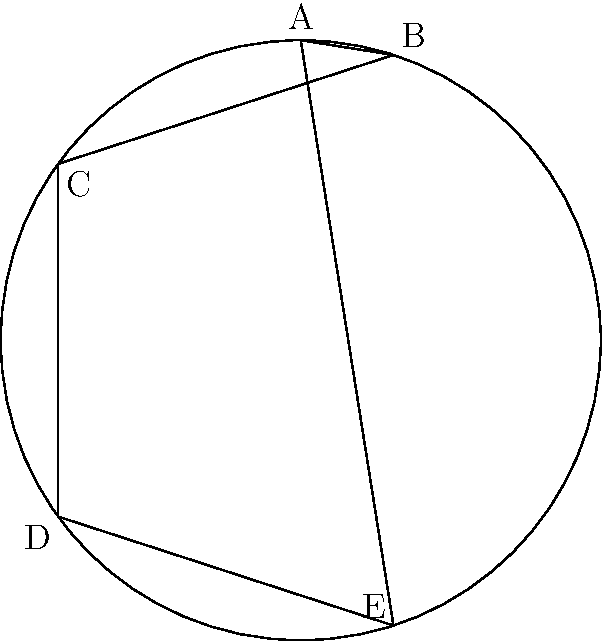In the hyperbolic plane model shown above, a regular pentagon ABCDE is inscribed in a circle. If the sum of the interior angles of this pentagon is $3\pi$ radians, what is the area of the pentagon in terms of $\pi$? Let's approach this step-by-step:

1) In Euclidean geometry, the sum of interior angles of a pentagon is $(5-2)\pi = 3\pi$ radians. However, in hyperbolic geometry, this sum is less than $3\pi$.

2) Let $\alpha$ be the measure of each interior angle of the regular pentagon. Given that the sum is $3\pi$, we have:

   $5\alpha = 3\pi$
   $\alpha = \frac{3\pi}{5}$

3) In hyperbolic geometry, the area of a polygon is given by:

   $Area = (n-2)\pi - \sum \theta_i$

   where $n$ is the number of sides and $\theta_i$ are the interior angles.

4) Substituting our values:

   $Area = (5-2)\pi - 5(\frac{3\pi}{5})$
   
   $= 3\pi - 3\pi$
   
   $= 0$

5) This might seem counterintuitive, but in hyperbolic geometry, as polygons get larger, more of their area is concentrated near their edges, and less in the center. A regular pentagon with interior angle sum of $3\pi$ is actually infinitely large in hyperbolic space, with its vertices lying on the "boundary at infinity" of the hyperbolic plane.
Answer: $0$ 